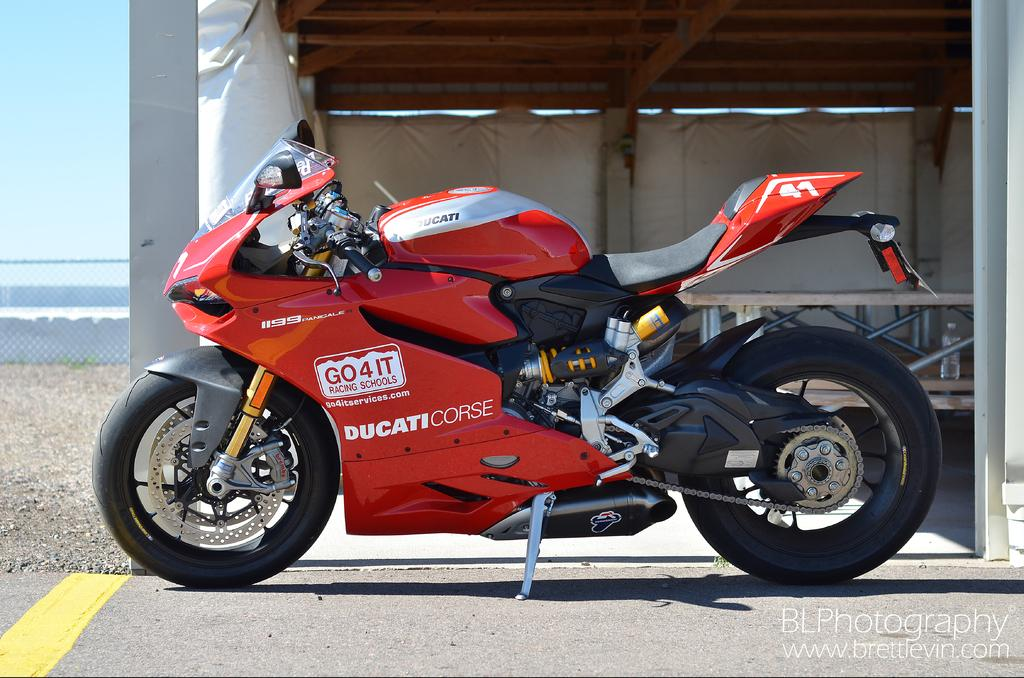<image>
Write a terse but informative summary of the picture. A red Ducati Corse motorcycle is parked by a picnic table. 